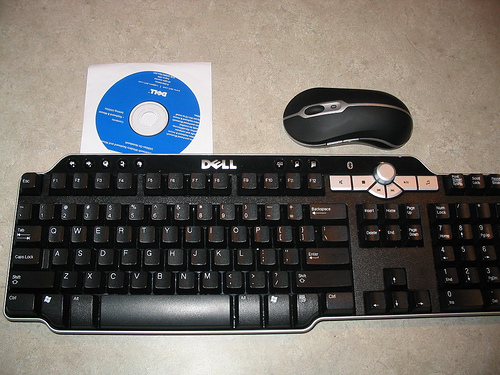Please identify all text content in this image. DELL W E 